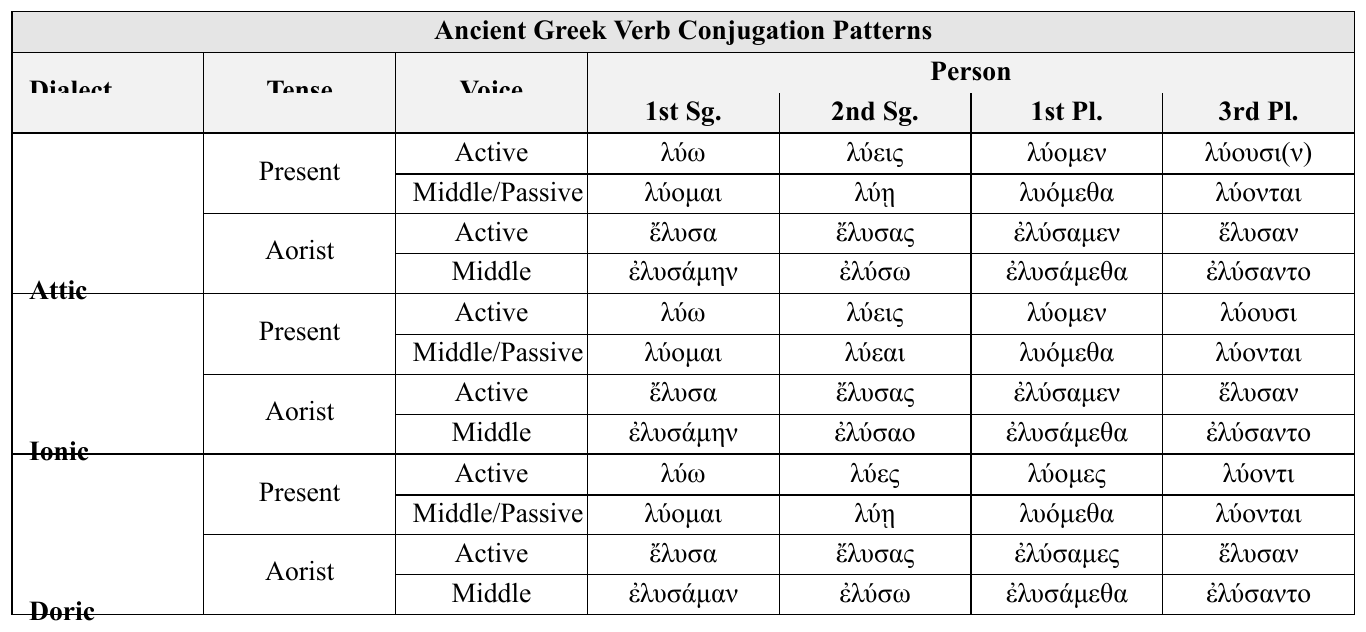What is the 1st Person Singular form of the Present Active tense in Attic dialect? The table shows that the 1st Person Singular form for the Present Active tense in the Attic dialect is "λύω".
Answer: λύω How many different voices are presented in the Aorist tense for the Ionic dialect? The table indicates there are two voices listed for the Aorist tense in the Ionic dialect: Active and Middle.
Answer: 2 What is the 2nd Person Singular form of the Present Middle/Passive tense in the Doric dialect? According to the table, the 2nd Person Singular form in the Present Middle/Passive tense for the Doric dialect is "λύῃ".
Answer: λύῃ In the Aorist tense, what is the 1st Person Plural form for the Active voice across all dialects? By examining the table, the 1st Person Plural form for the Active voice in the Aorist tense is "ἐλύσαμεν" for Attic and Ionic and "ἐλύσαμες" for Doric. Therefore, the answer varies by dialect.
Answer: Varies by dialect: Attic/Ionic: ἐλύσαμεν, Doric: ἐλύσαμες What is the difference between the 2nd Person Singular forms in Middle voice for Aorist in Ionic and Doric dialects? The Ionic form is "ἐλύσαο" and the Doric form is "ἐλύσω". The difference between these forms is that the Ionic has the ending "-σαο" while the Doric has "-σω".
Answer: Ionic: ἐλύσαο, Doric: ἐλύσω, difference is endings Is the 3rd Person Plural form the same in the Present Middle/Passive for Doric and Ionic dialects? The table shows that the 3rd Person Plural form in the Present Middle/Passive tense is "λύονται" for both the Doric and Ionic dialects. Therefore, it is the same.
Answer: Yes Which dialect has a different 2nd Person Singular Middle form in the Present tense compared to Attic? In comparing the 2nd Person Singular Middle form of the Present tense, the Ionic dialect has "λύεαι" while the Attic dialect has "λύῃ". Thus, the Ionic dialect is different.
Answer: Ionic What is the most frequent verb form ending for the 3rd Person Plural in the Present Active tense across all dialects? Upon reviewing the table, the most frequent ending for the 3rd Person Plural in the Present Active tense is "-ουσι" found in Attic and Ionic dialects. Doric has "-οντι".
Answer: "-ουσι" (Attic/Ionic) How do the 1st Person Singular Middle forms compare in the Aorist tense across the three dialects? From the table, the 1st Person Singular Middle form for Aorist tense is "ἐλυσάμην" for Attic, "ἐλυσάμην" for Ionic, and "ἐλυσάμαν" for Doric. The Attic and Ionic forms are identical while the Doric has a different ending.
Answer: Attic/Ionic: ἐλυσάμην, Doric: ἐλυσάμαν What is the only dialect that uses "λύοντι" in the Present Active tense for the 3rd Person Plural? The table specifies that only the Doric dialect uses "λύοντι" for the Present Active tense in the 3rd Person Plural, as the other dialects have "λύουσι" or "λύουσι(ν)".
Answer: Doric 